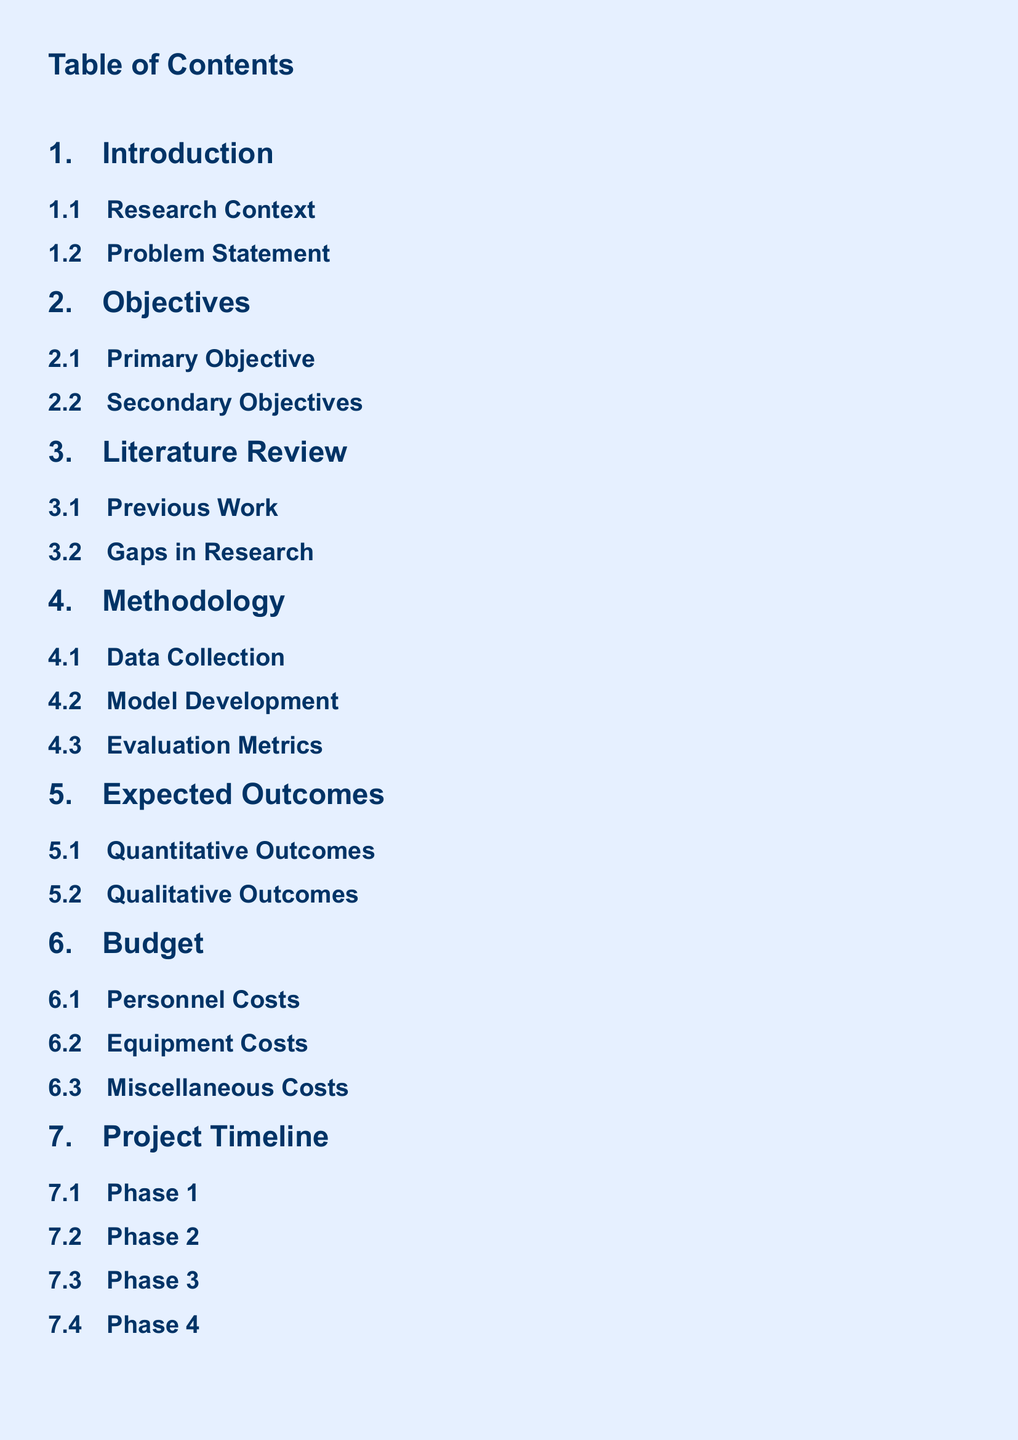what is the primary objective? The primary objective is outlined in the Objectives section of the document.
Answer: Primary Objective what is the focus of the literature review? The literature review highlights previous work and identifies gaps in research.
Answer: Previous Work how many phases are in the project timeline? The project timeline consists of multiple phases mentioned in the document.
Answer: Four what does the budget section include? The budget section details costs such as personnel, equipment, and miscellaneous expenses.
Answer: Personnel Costs what are the expected outcomes described in the proposal? The expected outcomes include both quantitative and qualitative aspects as detailed in the document.
Answer: Quantitative Outcomes which section discusses method development? Method development is a subsection of the Methodology section in the document.
Answer: Model Development what is the conclusion about future directions? The conclusion section discusses future directions as a part of the summary in the document.
Answer: Future Directions what type of costs are included in the budget? The budget includes various costs categorized in the document.
Answer: Equipment Costs 